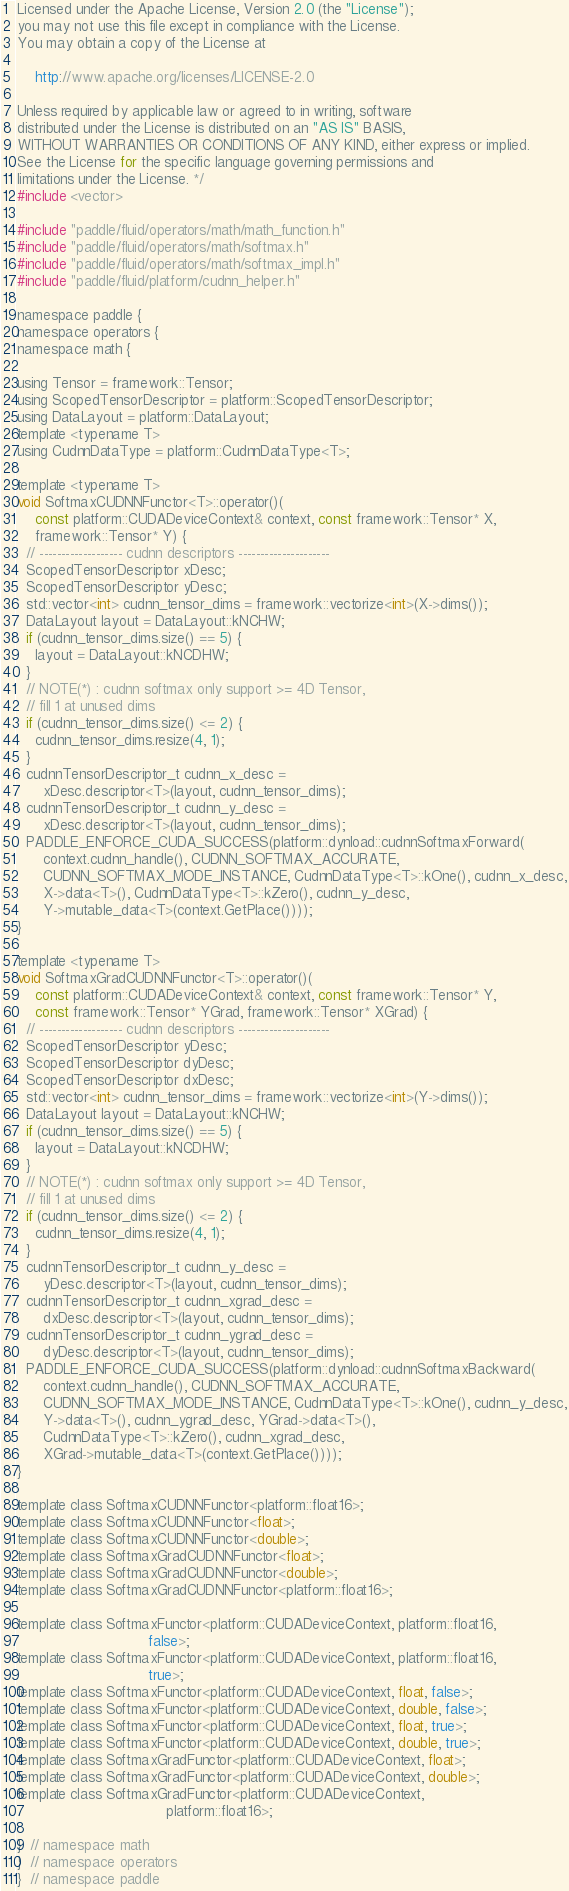<code> <loc_0><loc_0><loc_500><loc_500><_Cuda_>
Licensed under the Apache License, Version 2.0 (the "License");
you may not use this file except in compliance with the License.
You may obtain a copy of the License at

    http://www.apache.org/licenses/LICENSE-2.0

Unless required by applicable law or agreed to in writing, software
distributed under the License is distributed on an "AS IS" BASIS,
WITHOUT WARRANTIES OR CONDITIONS OF ANY KIND, either express or implied.
See the License for the specific language governing permissions and
limitations under the License. */
#include <vector>

#include "paddle/fluid/operators/math/math_function.h"
#include "paddle/fluid/operators/math/softmax.h"
#include "paddle/fluid/operators/math/softmax_impl.h"
#include "paddle/fluid/platform/cudnn_helper.h"

namespace paddle {
namespace operators {
namespace math {

using Tensor = framework::Tensor;
using ScopedTensorDescriptor = platform::ScopedTensorDescriptor;
using DataLayout = platform::DataLayout;
template <typename T>
using CudnnDataType = platform::CudnnDataType<T>;

template <typename T>
void SoftmaxCUDNNFunctor<T>::operator()(
    const platform::CUDADeviceContext& context, const framework::Tensor* X,
    framework::Tensor* Y) {
  // ------------------- cudnn descriptors ---------------------
  ScopedTensorDescriptor xDesc;
  ScopedTensorDescriptor yDesc;
  std::vector<int> cudnn_tensor_dims = framework::vectorize<int>(X->dims());
  DataLayout layout = DataLayout::kNCHW;
  if (cudnn_tensor_dims.size() == 5) {
    layout = DataLayout::kNCDHW;
  }
  // NOTE(*) : cudnn softmax only support >= 4D Tensor,
  // fill 1 at unused dims
  if (cudnn_tensor_dims.size() <= 2) {
    cudnn_tensor_dims.resize(4, 1);
  }
  cudnnTensorDescriptor_t cudnn_x_desc =
      xDesc.descriptor<T>(layout, cudnn_tensor_dims);
  cudnnTensorDescriptor_t cudnn_y_desc =
      xDesc.descriptor<T>(layout, cudnn_tensor_dims);
  PADDLE_ENFORCE_CUDA_SUCCESS(platform::dynload::cudnnSoftmaxForward(
      context.cudnn_handle(), CUDNN_SOFTMAX_ACCURATE,
      CUDNN_SOFTMAX_MODE_INSTANCE, CudnnDataType<T>::kOne(), cudnn_x_desc,
      X->data<T>(), CudnnDataType<T>::kZero(), cudnn_y_desc,
      Y->mutable_data<T>(context.GetPlace())));
}

template <typename T>
void SoftmaxGradCUDNNFunctor<T>::operator()(
    const platform::CUDADeviceContext& context, const framework::Tensor* Y,
    const framework::Tensor* YGrad, framework::Tensor* XGrad) {
  // ------------------- cudnn descriptors ---------------------
  ScopedTensorDescriptor yDesc;
  ScopedTensorDescriptor dyDesc;
  ScopedTensorDescriptor dxDesc;
  std::vector<int> cudnn_tensor_dims = framework::vectorize<int>(Y->dims());
  DataLayout layout = DataLayout::kNCHW;
  if (cudnn_tensor_dims.size() == 5) {
    layout = DataLayout::kNCDHW;
  }
  // NOTE(*) : cudnn softmax only support >= 4D Tensor,
  // fill 1 at unused dims
  if (cudnn_tensor_dims.size() <= 2) {
    cudnn_tensor_dims.resize(4, 1);
  }
  cudnnTensorDescriptor_t cudnn_y_desc =
      yDesc.descriptor<T>(layout, cudnn_tensor_dims);
  cudnnTensorDescriptor_t cudnn_xgrad_desc =
      dxDesc.descriptor<T>(layout, cudnn_tensor_dims);
  cudnnTensorDescriptor_t cudnn_ygrad_desc =
      dyDesc.descriptor<T>(layout, cudnn_tensor_dims);
  PADDLE_ENFORCE_CUDA_SUCCESS(platform::dynload::cudnnSoftmaxBackward(
      context.cudnn_handle(), CUDNN_SOFTMAX_ACCURATE,
      CUDNN_SOFTMAX_MODE_INSTANCE, CudnnDataType<T>::kOne(), cudnn_y_desc,
      Y->data<T>(), cudnn_ygrad_desc, YGrad->data<T>(),
      CudnnDataType<T>::kZero(), cudnn_xgrad_desc,
      XGrad->mutable_data<T>(context.GetPlace())));
}

template class SoftmaxCUDNNFunctor<platform::float16>;
template class SoftmaxCUDNNFunctor<float>;
template class SoftmaxCUDNNFunctor<double>;
template class SoftmaxGradCUDNNFunctor<float>;
template class SoftmaxGradCUDNNFunctor<double>;
template class SoftmaxGradCUDNNFunctor<platform::float16>;

template class SoftmaxFunctor<platform::CUDADeviceContext, platform::float16,
                              false>;
template class SoftmaxFunctor<platform::CUDADeviceContext, platform::float16,
                              true>;
template class SoftmaxFunctor<platform::CUDADeviceContext, float, false>;
template class SoftmaxFunctor<platform::CUDADeviceContext, double, false>;
template class SoftmaxFunctor<platform::CUDADeviceContext, float, true>;
template class SoftmaxFunctor<platform::CUDADeviceContext, double, true>;
template class SoftmaxGradFunctor<platform::CUDADeviceContext, float>;
template class SoftmaxGradFunctor<platform::CUDADeviceContext, double>;
template class SoftmaxGradFunctor<platform::CUDADeviceContext,
                                  platform::float16>;

}  // namespace math
}  // namespace operators
}  // namespace paddle
</code> 